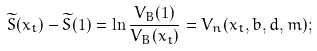Convert formula to latex. <formula><loc_0><loc_0><loc_500><loc_500>\widetilde { S } ( x _ { t } ) - \widetilde { S } ( 1 ) = \ln \frac { V _ { B } ( 1 ) } { V _ { B } ( x _ { t } ) } = { V } _ { n } ( x _ { t } , b , d , m ) ;</formula> 